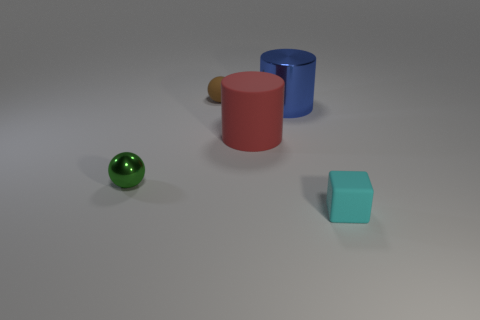The object that is in front of the big blue cylinder and behind the tiny green shiny sphere has what shape?
Your response must be concise. Cylinder. How many tiny matte things are behind the object left of the tiny ball that is behind the blue shiny object?
Keep it short and to the point. 1. What is the size of the other thing that is the same shape as the blue metal thing?
Your answer should be very brief. Large. Is there anything else that is the same size as the metallic cylinder?
Your answer should be compact. Yes. Are the cyan block right of the matte cylinder and the small green object made of the same material?
Give a very brief answer. No. There is a rubber object that is the same shape as the large blue metal thing; what color is it?
Give a very brief answer. Red. What number of other objects are there of the same color as the big matte object?
Your answer should be very brief. 0. There is a small matte object behind the small rubber block; does it have the same shape as the large object that is in front of the blue shiny cylinder?
Your answer should be compact. No. How many cubes are big red objects or small green things?
Your response must be concise. 0. Are there fewer big rubber objects behind the red rubber object than large yellow matte balls?
Make the answer very short. No. 